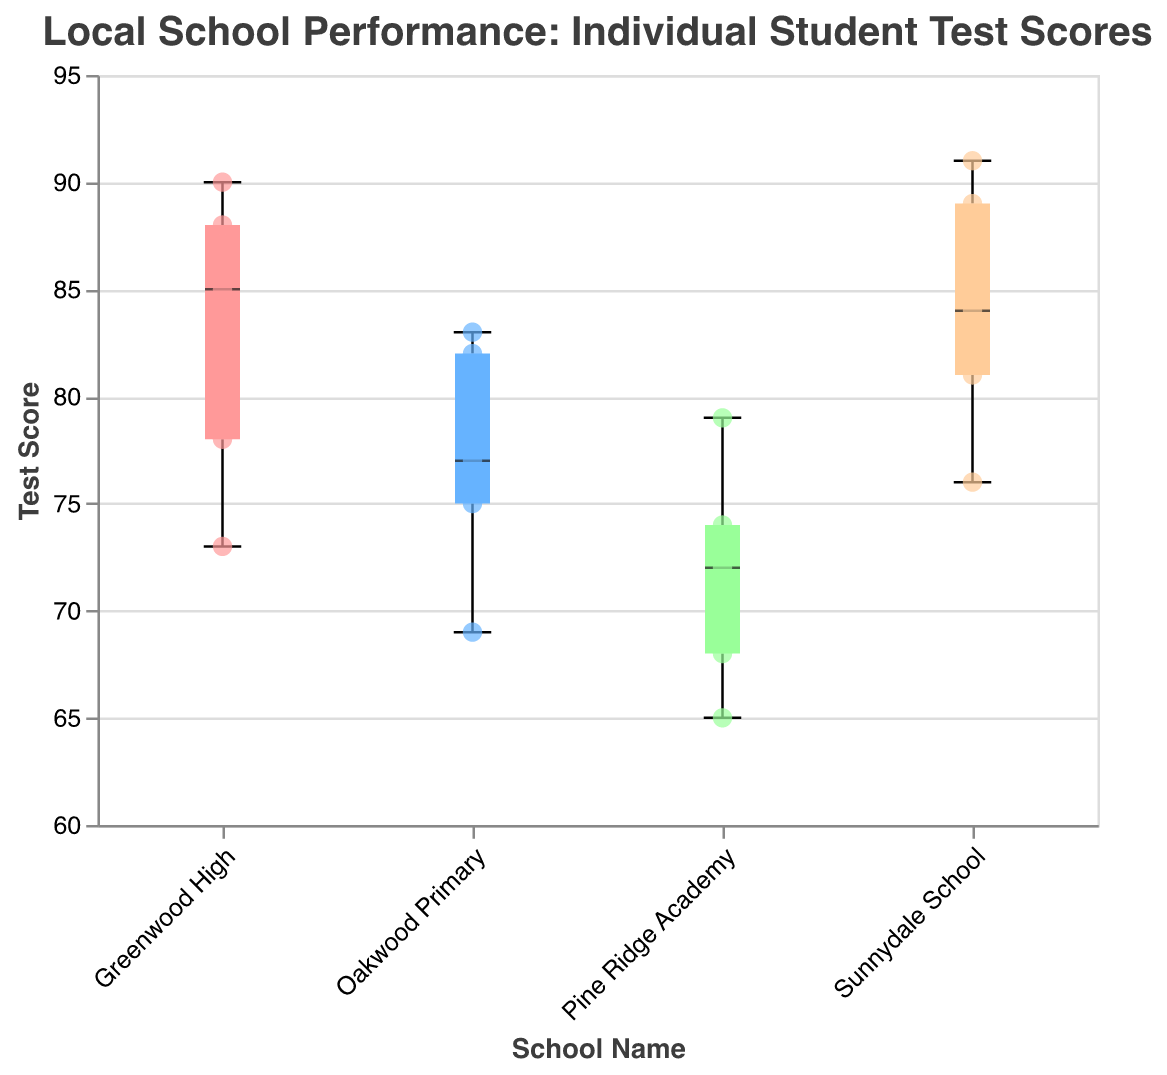What is the title of the figure? The title is usually placed at the top of the figure and provides information about what the figure represents. Here, it states "Local School Performance: Individual Student Test Scores".
Answer: Local School Performance: Individual Student Test Scores Which school has the highest individual test score? By examining the scatter points, we can see that "Sunnydale School" has the highest score with Chris Lewis scoring 91.
Answer: Sunnydale School What is the range of test scores for Greenwood High? The range is determined by the minimum and maximum test scores within the box plot for Greenwood High. The lowest score is Michael Johnson with 73, and the highest is David Wilson with 90.
Answer: 73 to 90 Which school has the lowest median test score? The median is represented by the thick line in the box plot's box. Pine Ridge Academy has the lowest median test score compared to the other schools.
Answer: Pine Ridge Academy How many scatter points are shown for Oakwood Primary? Counting all the individual scatter points (filled circles) for Oakwood Primary on the plot, we find there are five points.
Answer: 5 What is the median test score of Sunnydale School? The median is represented by the central line inside the box of the box plot. For Sunnydale School, this line corresponds to a score of around 84.
Answer: 84 How do the interquartile ranges (IQR) of Greenwood High and Pine Ridge Academy compare? The IQR is the length of the box in the box plot. Greenwood High has a much smaller IQR than Pine Ridge Academy, indicating less variability in test scores.
Answer: Greenwood High has a smaller IQR than Pine Ridge Academy Which school has the most consistent test scores? Consistency can be seen in the smaller range and IQR in the box plot. Greenwood High shows the smallest range and IQR, indicating the most consistent scores.
Answer: Greenwood High Are there any schools with outliers among the test scores? Outliers would appear as points outside the whiskers of the box plot. None of the schools have scatter points outside the whiskers, indicating no outliers.
Answer: No 